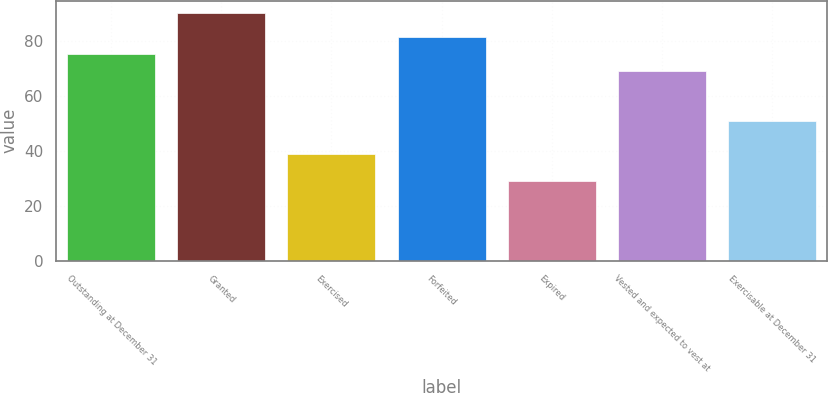Convert chart to OTSL. <chart><loc_0><loc_0><loc_500><loc_500><bar_chart><fcel>Outstanding at December 31<fcel>Granted<fcel>Exercised<fcel>Forfeited<fcel>Expired<fcel>Vested and expected to vest at<fcel>Exercisable at December 31<nl><fcel>75.12<fcel>89.97<fcel>38.58<fcel>81.21<fcel>29.11<fcel>69.03<fcel>50.76<nl></chart> 